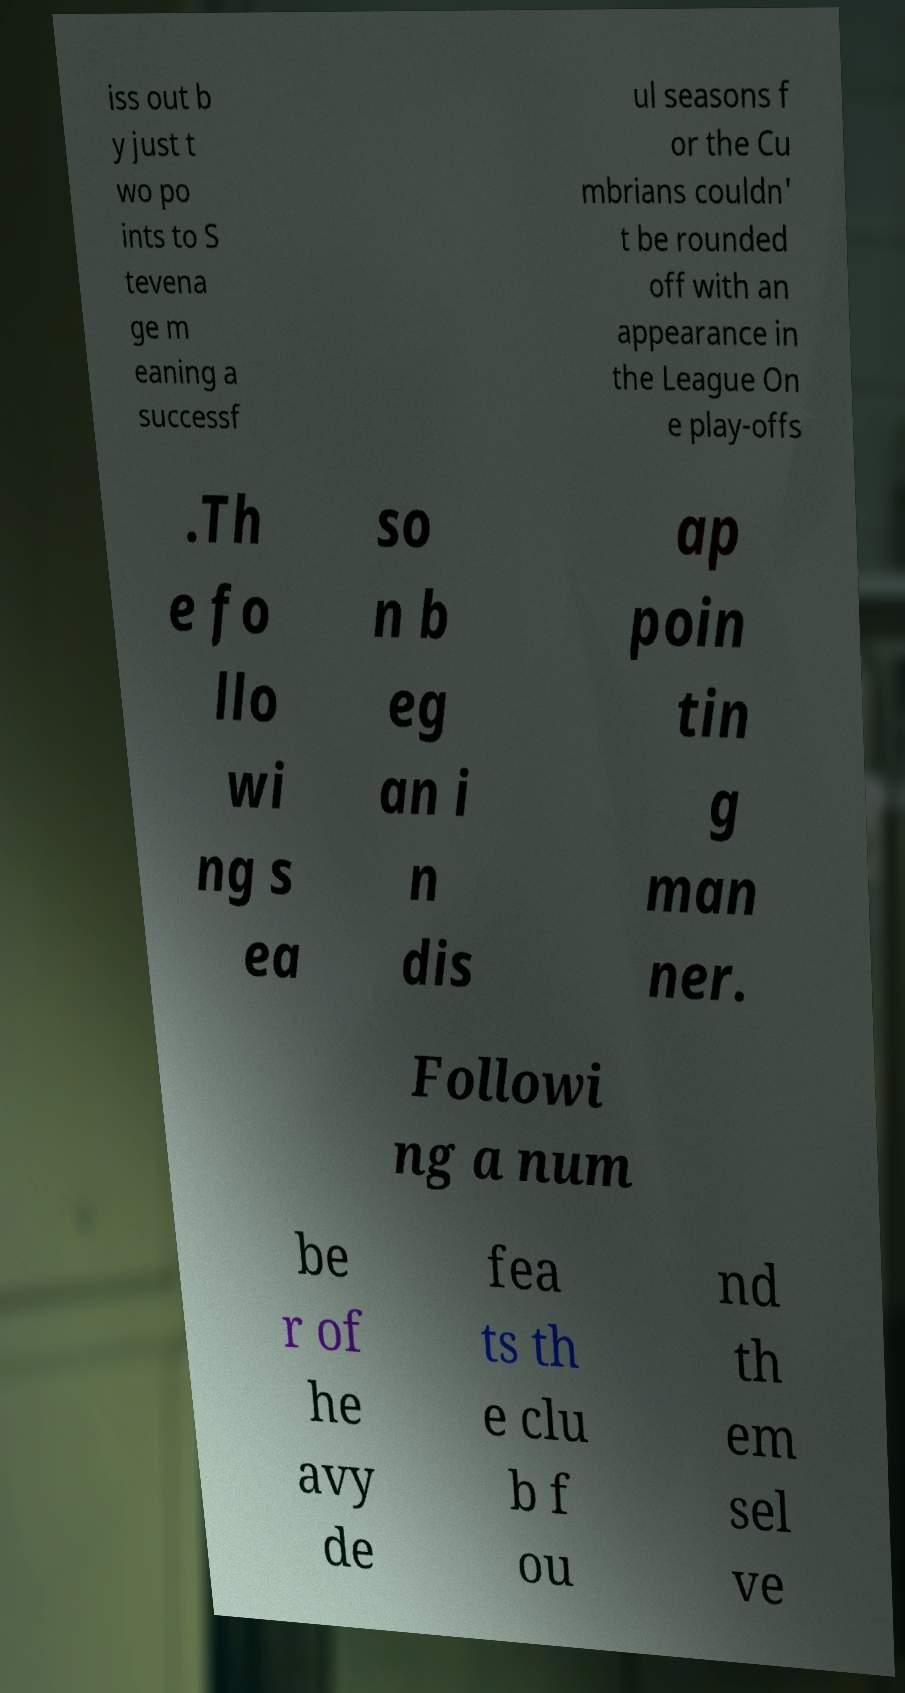There's text embedded in this image that I need extracted. Can you transcribe it verbatim? iss out b y just t wo po ints to S tevena ge m eaning a successf ul seasons f or the Cu mbrians couldn' t be rounded off with an appearance in the League On e play-offs .Th e fo llo wi ng s ea so n b eg an i n dis ap poin tin g man ner. Followi ng a num be r of he avy de fea ts th e clu b f ou nd th em sel ve 